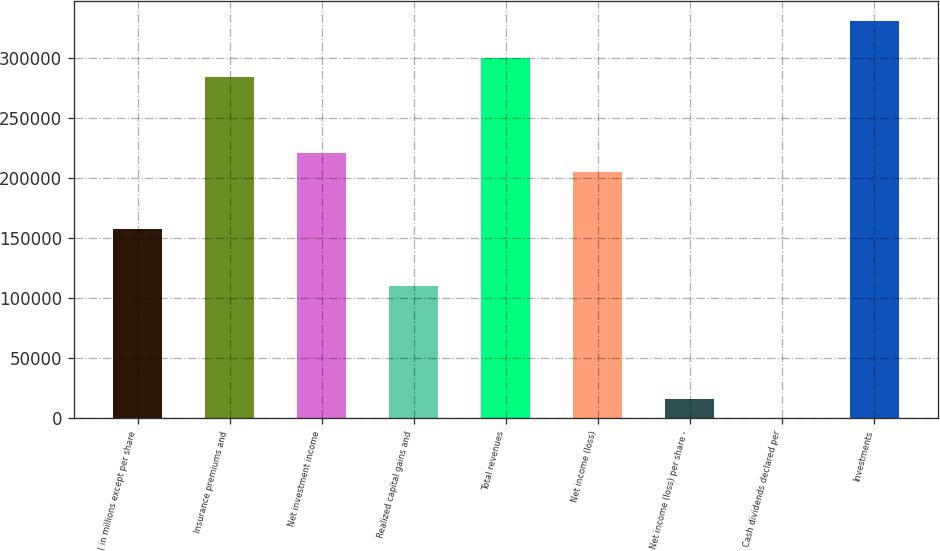Convert chart. <chart><loc_0><loc_0><loc_500><loc_500><bar_chart><fcel>( in millions except per share<fcel>Insurance premiums and<fcel>Net investment income<fcel>Realized capital gains and<fcel>Total revenues<fcel>Net income (loss)<fcel>Net income (loss) per share -<fcel>Cash dividends declared per<fcel>Investments<nl><fcel>157554<fcel>283596<fcel>220575<fcel>110288<fcel>299351<fcel>204820<fcel>15756.7<fcel>1.4<fcel>330862<nl></chart> 